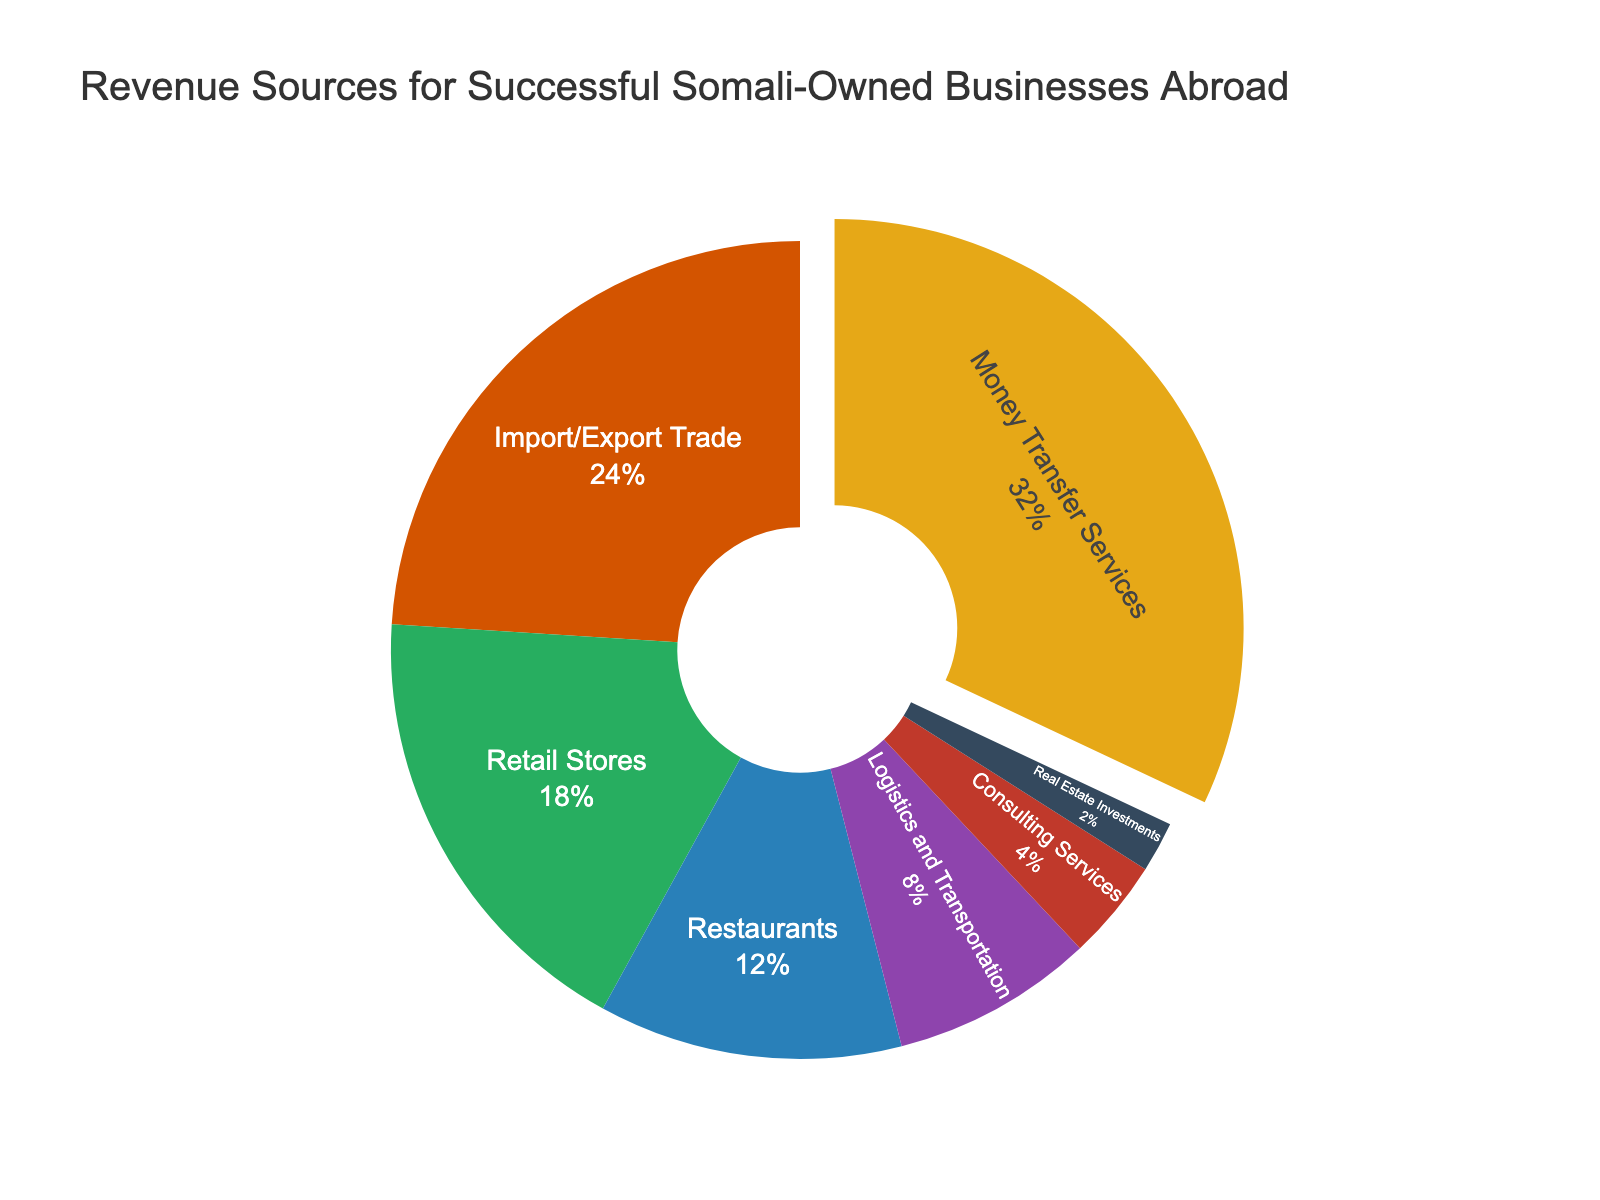What percentage of revenue comes from Money Transfer Services and Import/Export Trade combined? Add the percentages from Money Transfer Services (32%) and Import/Export Trade (24%). 32 + 24 = 56
Answer: 56% Which revenue source contributes the least to the total revenue? Identify the smallest percentage in the pie chart. Real Estate Investments has the smallest percentage of 2%.
Answer: Real Estate Investments How much higher is the percentage of revenue from Retail Stores compared to Logistics and Transportation? Subtract the percentage of Logistics and Transportation (8%) from the percentage of Retail Stores (18%). 18 - 8 = 10
Answer: 10% What is the difference in revenue contribution between Restaurants and Consulting Services? Subtract the percentage of Consulting Services (4%) from the percentage of Restaurants (12%). 12 - 4 = 8
Answer: 8% Which segment has a slightly pulled out section in the pie chart? Observe the pie chart to see which segment has a pulled out section. The Money Transfer Services section is slightly pulled out in the pie chart.
Answer: Money Transfer Services What cumulative percentage of the total revenue is generated by Restaurants, Logistics and Transportation, and Consulting Services combined? Add the percentages from Restaurants (12%), Logistics and Transportation (8%), and Consulting Services (4%). 12 + 8 + 4 = 24
Answer: 24% Is the revenue contribution from Retail Stores greater than from Import/Export Trade? Compare the percentages of Retail Stores (18%) and Import/Export Trade (24%). 18 is less than 24, so the revenue from Retail Stores is not greater.
Answer: No If the percentages of Consulting Services and Real Estate Investments were doubled, what would their new combined total percentage be? Double the percentages of Consulting Services (4% * 2 = 8%) and Real Estate Investments (2% * 2 = 4%). Add the new values. 8 + 4 = 12
Answer: 12% What visual element is used to highlight the section of the chart representing Money Transfer Services? Look at the chart to identify any distinctive visual features used. The Money Transfer Services section is highlighted by being slightly pulled out from the pie chart.
Answer: Pulled out section Which revenue source is represented with the color green in the pie chart? Identify the section colored green. The green color is associated with Retail Stores.
Answer: Retail Stores 